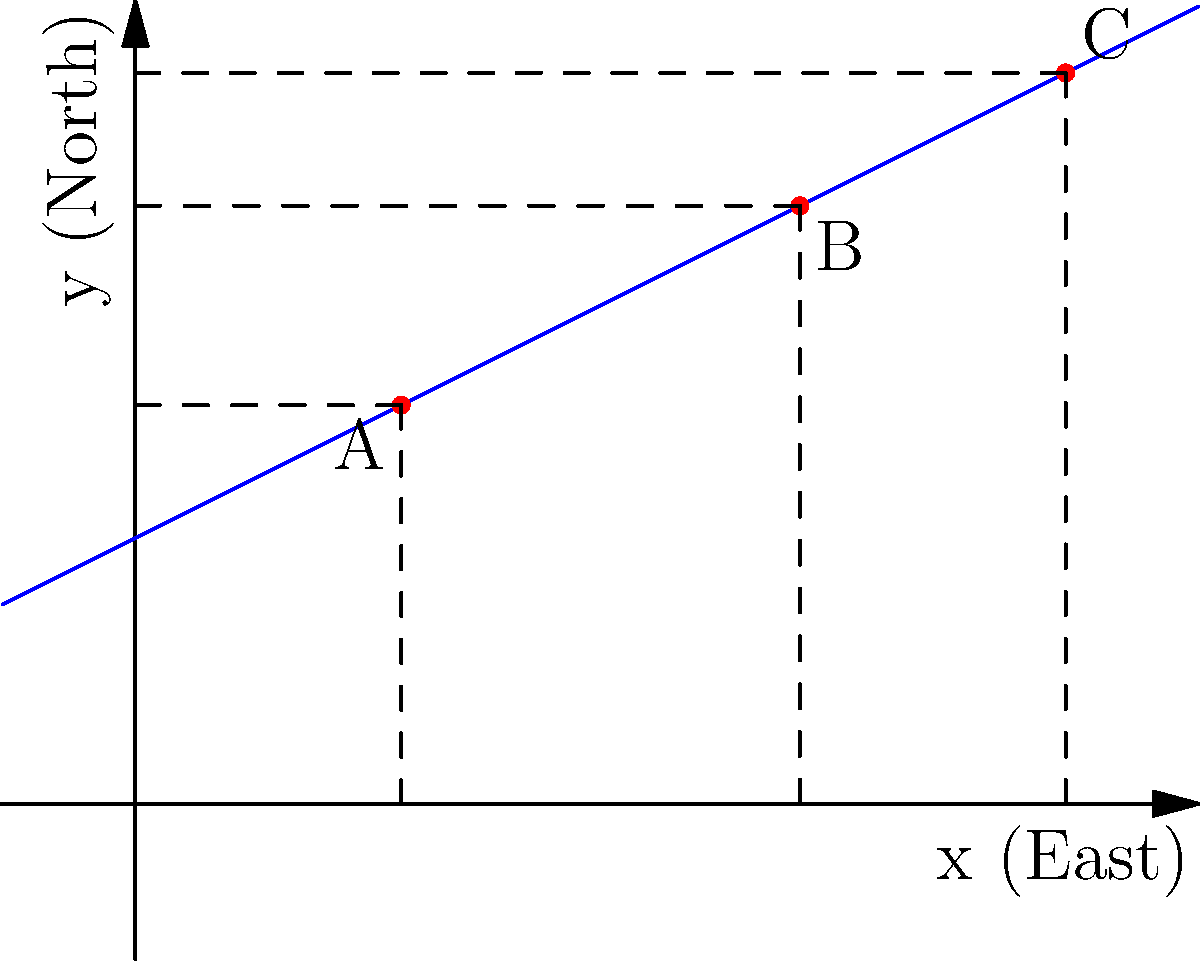You're planning to plant a new row of grapevines in your vineyard to maximize sun exposure. The blue line represents the optimal planting line for maximum sunlight. You've identified three potential starting points for your new row: A(2,3), B(5,4.5), and C(7,5.5). Which of these points lies closest to the optimal planting line? Calculate the vertical distance from each point to the line to determine the best starting point. To find the point closest to the optimal planting line, we need to calculate the vertical distance from each point to the line. The line's equation is $y = 0.5x + 2$.

1. For point A(2,3):
   - Expected y-value on the line: $y = 0.5(2) + 2 = 3$
   - Actual y-value of point A: 3
   - Vertical distance: $|3 - 3| = 0$

2. For point B(5,4.5):
   - Expected y-value on the line: $y = 0.5(5) + 2 = 4.5$
   - Actual y-value of point B: 4.5
   - Vertical distance: $|4.5 - 4.5| = 0$

3. For point C(7,5.5):
   - Expected y-value on the line: $y = 0.5(7) + 2 = 5.5$
   - Actual y-value of point C: 5.5
   - Vertical distance: $|5.5 - 5.5| = 0$

All three points have a vertical distance of 0 from the optimal planting line, meaning they all lie exactly on the line.
Answer: All points (A, B, and C) are equally optimal; they all lie on the line. 